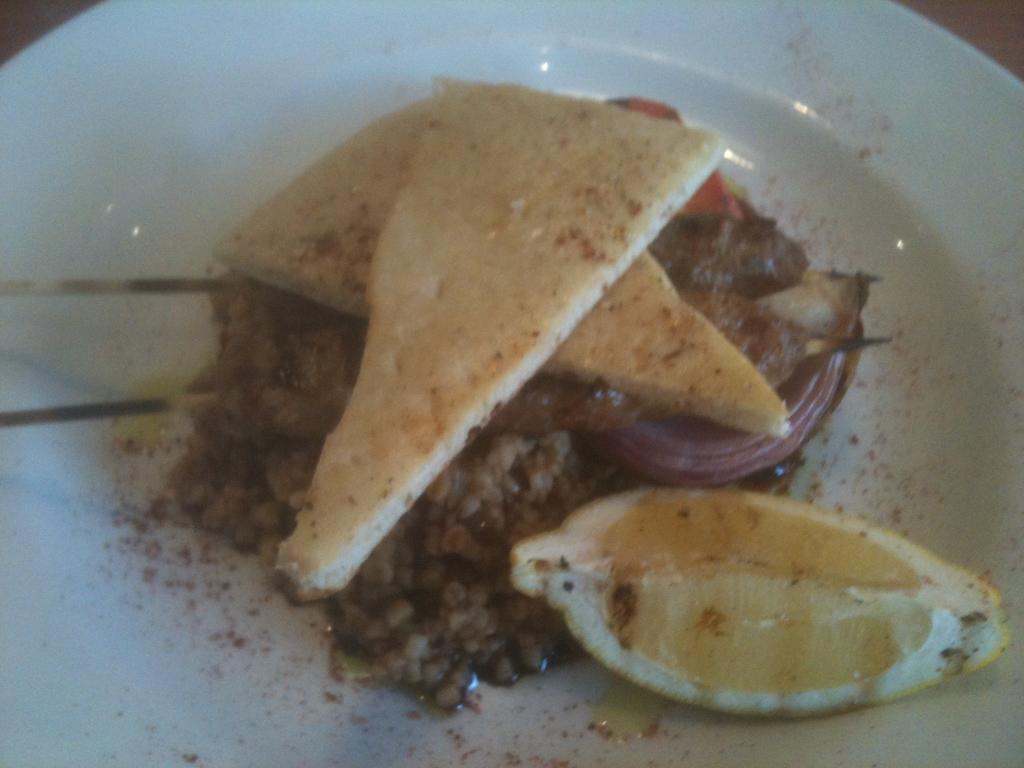Please provide a concise description of this image. In this image we can see a plate with some food items. 